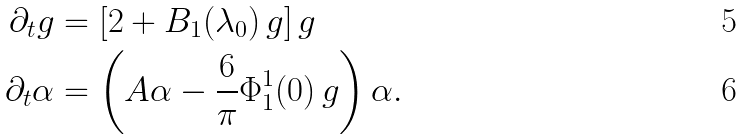<formula> <loc_0><loc_0><loc_500><loc_500>\partial _ { t } g & = \left [ 2 + B _ { 1 } ( \lambda _ { 0 } ) \, g \right ] g \\ \partial _ { t } \alpha & = \left ( A \alpha - \frac { 6 } { \pi } \Phi ^ { 1 } _ { 1 } ( 0 ) \, g \right ) \alpha .</formula> 